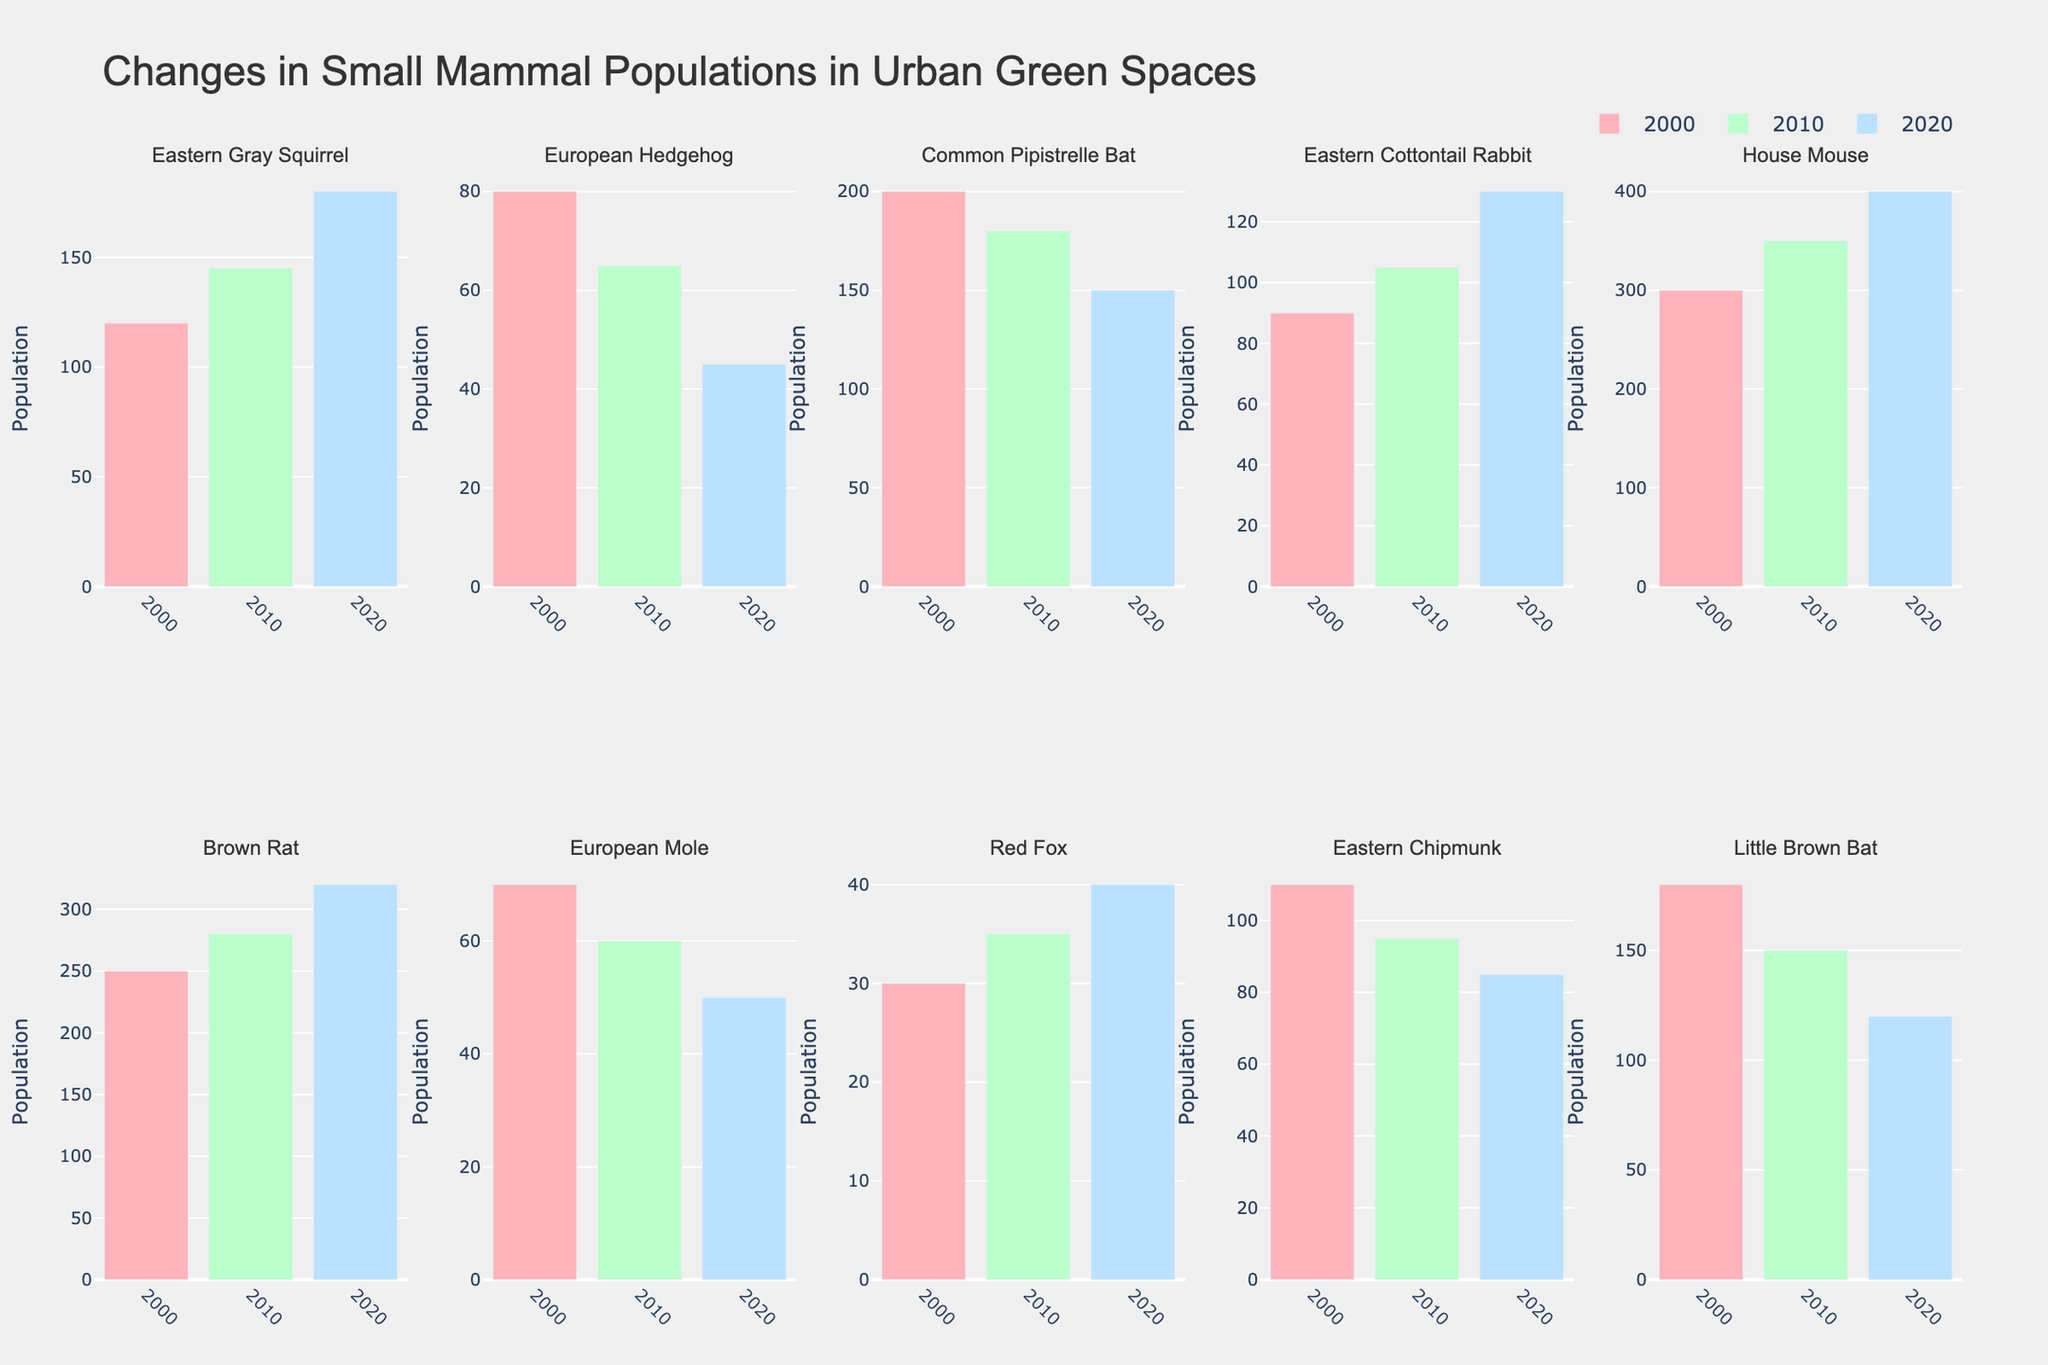Which species has the highest population in 2020? Look at the bar heights for the year 2020 across all species; the House Mouse has the highest population with a bar representing 400.
Answer: House Mouse What's the total population of Eastern Gray Squirrel over the three years? Add the population numbers for Eastern Gray Squirrel for 2000, 2010, and 2020: 120 + 145 + 180 = 445.
Answer: 445 How does the population trend for the European Hedgehog change from 2000 to 2020? Check the bars for European Hedgehog for the years 2000, 2010, and 2020. The trend shows a decrease from 80 in 2000, to 65 in 2010, and finally to 45 in 2020.
Answer: Decreases Which species had a higher population in 2010: Eastern Chipmunk or European Mole? Compare the height of the 2010 bars for Eastern Chipmunk and European Mole: Eastern Chipmunk has a population of 95, while European Mole has a population of 60.
Answer: Eastern Chipmunk What is the average population of the Red Fox over the three decades? Add the populations for Red Fox for 2000, 2010, and 2020, and divide by 3: (30 + 35 + 40) / 3 = 35.
Answer: 35 Compared to 2000, how has the House Mouse population changed in 2020? Determine the difference between 2020 and 2000 populations for the House Mouse: 400 (2020) - 300 (2000) = 100.
Answer: Increased by 100 Which species had a decreasing trend in population from 2000 to 2020 and by how much did the Eastern Cottontail Rabbit population increase from 2000 to 2020? Identify species whose bar heights are lower in 2020 compared to 2000: European Hedgehog, Common Pipistrelle Bat, European Mole, Eastern Chipmunk, Little Brown Bat. For the Eastern Cottontail Rabbit, subtract the 2000 population from the 2020 population: 130 - 90 = 40.
Answer: 5 species, increased by 40 Which species saw a rise in population from 2000 to 2020 but shows a decline from 2010 to 2020? Look at the trend for each species, finding those with a larger bar in 2020 compared to 2000 but a smaller bar in 2020 compared to 2010: Common Pipistrelle Bat, Eastern Chipmunk, Little Brown Bat.
Answer: Common Pipistrelle Bat, Eastern Chipmunk, Little Brown Bat How much did the Brown Rat population grow from 2000 to 2020? Subtract the population in 2000 from the population in 2020 for Brown Rat: 320 (2020) - 250 (2000) = 70.
Answer: 70 What is the population trend for the Common Pipistrelle Bat from 2000 to 2020 and what does it imply about urbanization effects? Check the population for Common Pipistrelle Bat in 2000 (200), 2010 (180), and 2020 (150). The trend shows a steady decline, suggesting that urbanization may be negatively impacting this species.
Answer: Steady decline, negative impact of urbanization 